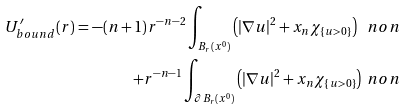<formula> <loc_0><loc_0><loc_500><loc_500>U _ { b o u n d } ^ { \prime } ( r ) = - ( n + 1 ) r ^ { - n - 2 } \int _ { B _ { r } ( x ^ { 0 } ) } \left ( { | \nabla u | } ^ { 2 } + x _ { n } \chi _ { \{ u > 0 \} } \right ) \ n o n \\ + r ^ { - n - 1 } \int _ { \partial B _ { r } ( x ^ { 0 } ) } \left ( { | \nabla u | } ^ { 2 } + x _ { n } \chi _ { \{ u > 0 \} } \right ) \ n o n</formula> 